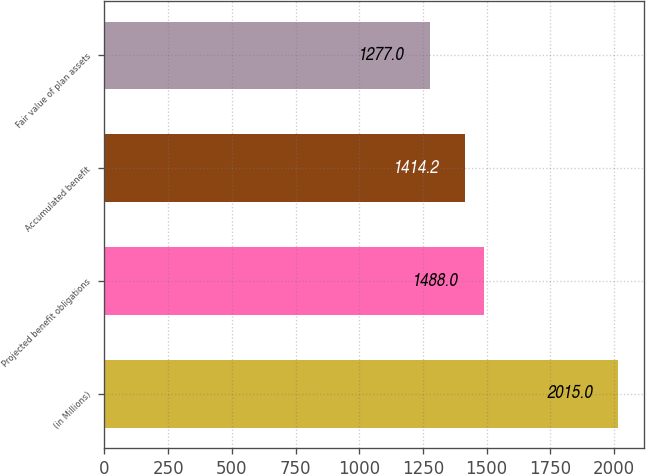Convert chart. <chart><loc_0><loc_0><loc_500><loc_500><bar_chart><fcel>(in Millions)<fcel>Projected benefit obligations<fcel>Accumulated benefit<fcel>Fair value of plan assets<nl><fcel>2015<fcel>1488<fcel>1414.2<fcel>1277<nl></chart> 